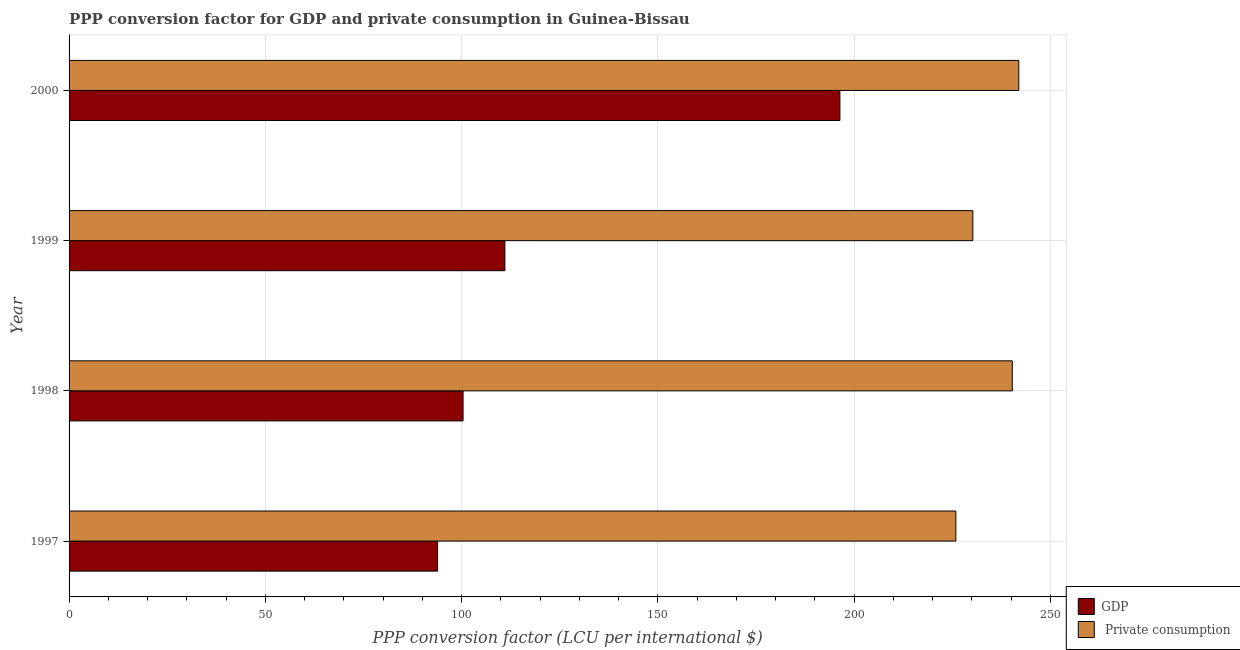How many different coloured bars are there?
Your answer should be very brief. 2. How many groups of bars are there?
Provide a short and direct response. 4. How many bars are there on the 4th tick from the bottom?
Offer a terse response. 2. What is the label of the 2nd group of bars from the top?
Provide a succinct answer. 1999. What is the ppp conversion factor for private consumption in 2000?
Give a very brief answer. 241.97. Across all years, what is the maximum ppp conversion factor for private consumption?
Your answer should be very brief. 241.97. Across all years, what is the minimum ppp conversion factor for gdp?
Your answer should be very brief. 93.89. In which year was the ppp conversion factor for private consumption minimum?
Give a very brief answer. 1997. What is the total ppp conversion factor for private consumption in the graph?
Your answer should be very brief. 938.48. What is the difference between the ppp conversion factor for private consumption in 1999 and that in 2000?
Your answer should be very brief. -11.71. What is the difference between the ppp conversion factor for gdp in 2000 and the ppp conversion factor for private consumption in 1999?
Make the answer very short. -33.87. What is the average ppp conversion factor for private consumption per year?
Offer a terse response. 234.62. In the year 1997, what is the difference between the ppp conversion factor for gdp and ppp conversion factor for private consumption?
Your answer should be very brief. -132.05. What is the ratio of the ppp conversion factor for private consumption in 1998 to that in 1999?
Offer a very short reply. 1.04. Is the ppp conversion factor for private consumption in 1997 less than that in 2000?
Give a very brief answer. Yes. What is the difference between the highest and the second highest ppp conversion factor for gdp?
Offer a very short reply. 85.36. What is the difference between the highest and the lowest ppp conversion factor for gdp?
Ensure brevity in your answer.  102.5. In how many years, is the ppp conversion factor for gdp greater than the average ppp conversion factor for gdp taken over all years?
Your answer should be very brief. 1. What does the 2nd bar from the top in 2000 represents?
Provide a succinct answer. GDP. What does the 2nd bar from the bottom in 2000 represents?
Offer a terse response.  Private consumption. How many bars are there?
Offer a very short reply. 8. How many years are there in the graph?
Ensure brevity in your answer.  4. Does the graph contain grids?
Ensure brevity in your answer.  Yes. What is the title of the graph?
Offer a terse response. PPP conversion factor for GDP and private consumption in Guinea-Bissau. Does "Total Population" appear as one of the legend labels in the graph?
Provide a short and direct response. No. What is the label or title of the X-axis?
Keep it short and to the point. PPP conversion factor (LCU per international $). What is the PPP conversion factor (LCU per international $) of GDP in 1997?
Provide a short and direct response. 93.89. What is the PPP conversion factor (LCU per international $) in  Private consumption in 1997?
Offer a terse response. 225.94. What is the PPP conversion factor (LCU per international $) in GDP in 1998?
Your answer should be very brief. 100.38. What is the PPP conversion factor (LCU per international $) of  Private consumption in 1998?
Provide a succinct answer. 240.31. What is the PPP conversion factor (LCU per international $) of GDP in 1999?
Make the answer very short. 111.04. What is the PPP conversion factor (LCU per international $) in  Private consumption in 1999?
Provide a short and direct response. 230.26. What is the PPP conversion factor (LCU per international $) of GDP in 2000?
Give a very brief answer. 196.39. What is the PPP conversion factor (LCU per international $) of  Private consumption in 2000?
Your answer should be compact. 241.97. Across all years, what is the maximum PPP conversion factor (LCU per international $) of GDP?
Your answer should be very brief. 196.39. Across all years, what is the maximum PPP conversion factor (LCU per international $) in  Private consumption?
Your answer should be very brief. 241.97. Across all years, what is the minimum PPP conversion factor (LCU per international $) in GDP?
Make the answer very short. 93.89. Across all years, what is the minimum PPP conversion factor (LCU per international $) in  Private consumption?
Offer a terse response. 225.94. What is the total PPP conversion factor (LCU per international $) of GDP in the graph?
Provide a succinct answer. 501.7. What is the total PPP conversion factor (LCU per international $) in  Private consumption in the graph?
Your answer should be very brief. 938.48. What is the difference between the PPP conversion factor (LCU per international $) of GDP in 1997 and that in 1998?
Keep it short and to the point. -6.49. What is the difference between the PPP conversion factor (LCU per international $) of  Private consumption in 1997 and that in 1998?
Offer a very short reply. -14.38. What is the difference between the PPP conversion factor (LCU per international $) of GDP in 1997 and that in 1999?
Your answer should be very brief. -17.15. What is the difference between the PPP conversion factor (LCU per international $) in  Private consumption in 1997 and that in 1999?
Your answer should be very brief. -4.32. What is the difference between the PPP conversion factor (LCU per international $) in GDP in 1997 and that in 2000?
Your answer should be very brief. -102.5. What is the difference between the PPP conversion factor (LCU per international $) in  Private consumption in 1997 and that in 2000?
Your response must be concise. -16.04. What is the difference between the PPP conversion factor (LCU per international $) of GDP in 1998 and that in 1999?
Provide a succinct answer. -10.65. What is the difference between the PPP conversion factor (LCU per international $) in  Private consumption in 1998 and that in 1999?
Your response must be concise. 10.05. What is the difference between the PPP conversion factor (LCU per international $) in GDP in 1998 and that in 2000?
Give a very brief answer. -96.01. What is the difference between the PPP conversion factor (LCU per international $) of  Private consumption in 1998 and that in 2000?
Your response must be concise. -1.66. What is the difference between the PPP conversion factor (LCU per international $) in GDP in 1999 and that in 2000?
Give a very brief answer. -85.36. What is the difference between the PPP conversion factor (LCU per international $) of  Private consumption in 1999 and that in 2000?
Your response must be concise. -11.71. What is the difference between the PPP conversion factor (LCU per international $) in GDP in 1997 and the PPP conversion factor (LCU per international $) in  Private consumption in 1998?
Keep it short and to the point. -146.42. What is the difference between the PPP conversion factor (LCU per international $) of GDP in 1997 and the PPP conversion factor (LCU per international $) of  Private consumption in 1999?
Give a very brief answer. -136.37. What is the difference between the PPP conversion factor (LCU per international $) of GDP in 1997 and the PPP conversion factor (LCU per international $) of  Private consumption in 2000?
Provide a succinct answer. -148.09. What is the difference between the PPP conversion factor (LCU per international $) in GDP in 1998 and the PPP conversion factor (LCU per international $) in  Private consumption in 1999?
Provide a succinct answer. -129.88. What is the difference between the PPP conversion factor (LCU per international $) in GDP in 1998 and the PPP conversion factor (LCU per international $) in  Private consumption in 2000?
Provide a short and direct response. -141.59. What is the difference between the PPP conversion factor (LCU per international $) of GDP in 1999 and the PPP conversion factor (LCU per international $) of  Private consumption in 2000?
Ensure brevity in your answer.  -130.94. What is the average PPP conversion factor (LCU per international $) of GDP per year?
Provide a short and direct response. 125.43. What is the average PPP conversion factor (LCU per international $) in  Private consumption per year?
Your answer should be very brief. 234.62. In the year 1997, what is the difference between the PPP conversion factor (LCU per international $) of GDP and PPP conversion factor (LCU per international $) of  Private consumption?
Ensure brevity in your answer.  -132.05. In the year 1998, what is the difference between the PPP conversion factor (LCU per international $) of GDP and PPP conversion factor (LCU per international $) of  Private consumption?
Provide a succinct answer. -139.93. In the year 1999, what is the difference between the PPP conversion factor (LCU per international $) of GDP and PPP conversion factor (LCU per international $) of  Private consumption?
Provide a short and direct response. -119.22. In the year 2000, what is the difference between the PPP conversion factor (LCU per international $) of GDP and PPP conversion factor (LCU per international $) of  Private consumption?
Offer a very short reply. -45.58. What is the ratio of the PPP conversion factor (LCU per international $) of GDP in 1997 to that in 1998?
Your answer should be compact. 0.94. What is the ratio of the PPP conversion factor (LCU per international $) in  Private consumption in 1997 to that in 1998?
Offer a very short reply. 0.94. What is the ratio of the PPP conversion factor (LCU per international $) of GDP in 1997 to that in 1999?
Make the answer very short. 0.85. What is the ratio of the PPP conversion factor (LCU per international $) of  Private consumption in 1997 to that in 1999?
Your response must be concise. 0.98. What is the ratio of the PPP conversion factor (LCU per international $) in GDP in 1997 to that in 2000?
Keep it short and to the point. 0.48. What is the ratio of the PPP conversion factor (LCU per international $) of  Private consumption in 1997 to that in 2000?
Your answer should be compact. 0.93. What is the ratio of the PPP conversion factor (LCU per international $) in GDP in 1998 to that in 1999?
Make the answer very short. 0.9. What is the ratio of the PPP conversion factor (LCU per international $) in  Private consumption in 1998 to that in 1999?
Your response must be concise. 1.04. What is the ratio of the PPP conversion factor (LCU per international $) in GDP in 1998 to that in 2000?
Offer a terse response. 0.51. What is the ratio of the PPP conversion factor (LCU per international $) of  Private consumption in 1998 to that in 2000?
Make the answer very short. 0.99. What is the ratio of the PPP conversion factor (LCU per international $) of GDP in 1999 to that in 2000?
Provide a succinct answer. 0.57. What is the ratio of the PPP conversion factor (LCU per international $) in  Private consumption in 1999 to that in 2000?
Offer a terse response. 0.95. What is the difference between the highest and the second highest PPP conversion factor (LCU per international $) in GDP?
Keep it short and to the point. 85.36. What is the difference between the highest and the second highest PPP conversion factor (LCU per international $) in  Private consumption?
Make the answer very short. 1.66. What is the difference between the highest and the lowest PPP conversion factor (LCU per international $) in GDP?
Keep it short and to the point. 102.5. What is the difference between the highest and the lowest PPP conversion factor (LCU per international $) of  Private consumption?
Provide a short and direct response. 16.04. 